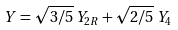<formula> <loc_0><loc_0><loc_500><loc_500>Y = \sqrt { 3 / 5 } \, Y _ { 2 R } + \sqrt { 2 / 5 } \, Y _ { 4 }</formula> 